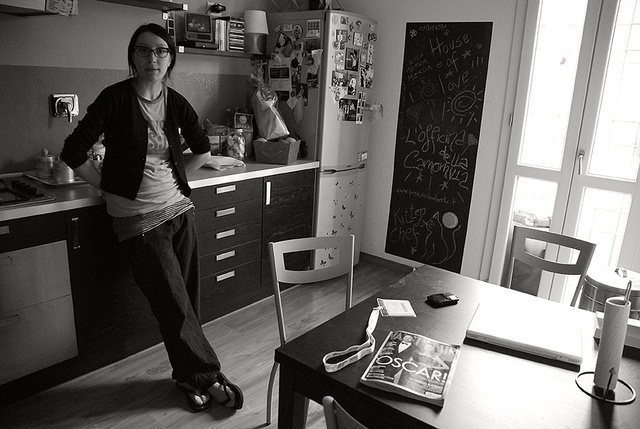Describe the objects in this image and their specific colors. I can see dining table in gray, white, black, and darkgray tones, people in gray, black, and darkgray tones, refrigerator in gray, black, and darkgray tones, oven in gray and black tones, and laptop in gray, white, and darkgray tones in this image. 